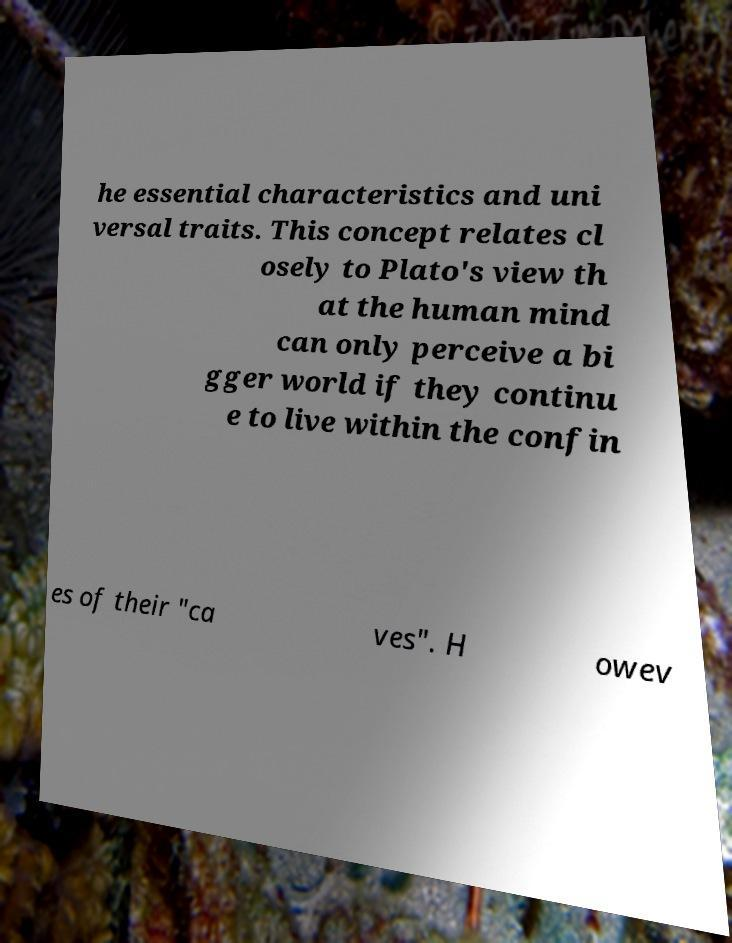Could you assist in decoding the text presented in this image and type it out clearly? he essential characteristics and uni versal traits. This concept relates cl osely to Plato's view th at the human mind can only perceive a bi gger world if they continu e to live within the confin es of their "ca ves". H owev 